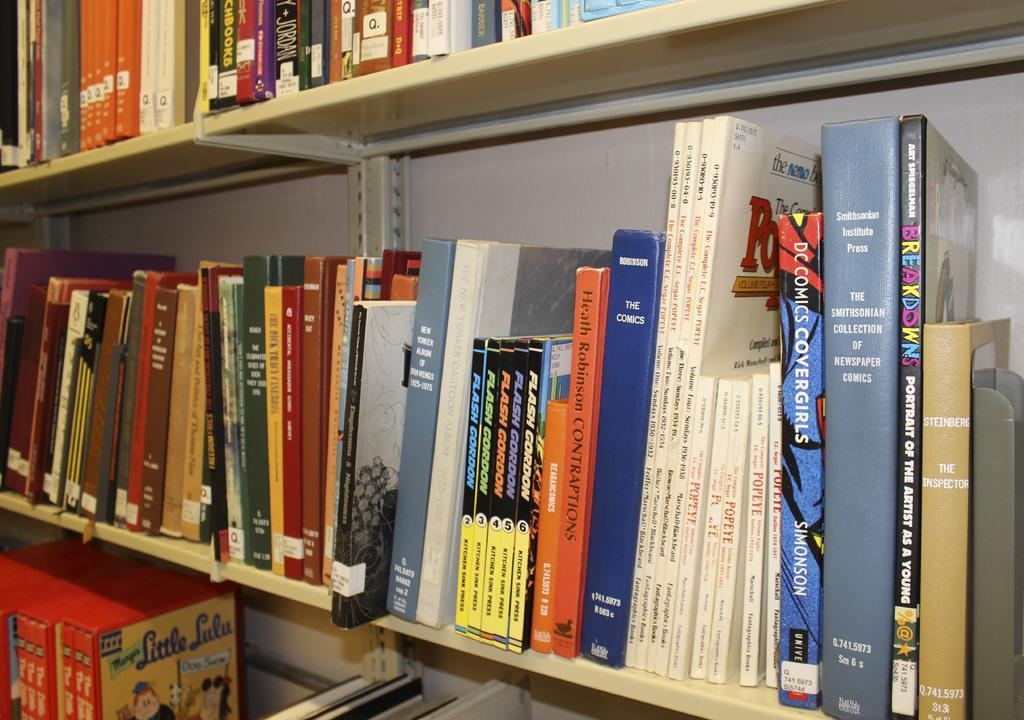Describe this image in one or two sentences. In this image, we can see books which are in the shelves. 